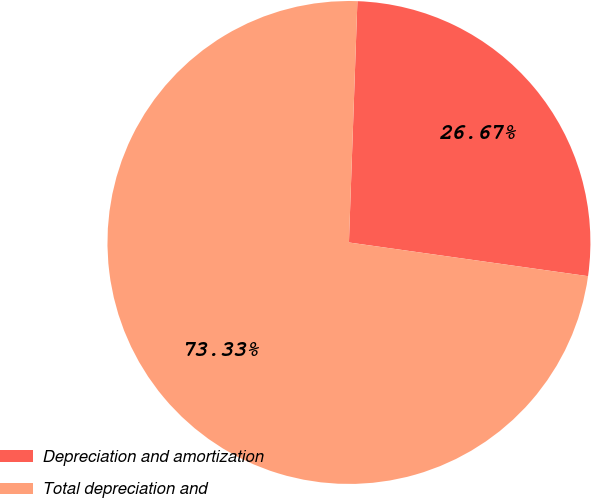Convert chart to OTSL. <chart><loc_0><loc_0><loc_500><loc_500><pie_chart><fcel>Depreciation and amortization<fcel>Total depreciation and<nl><fcel>26.67%<fcel>73.33%<nl></chart> 